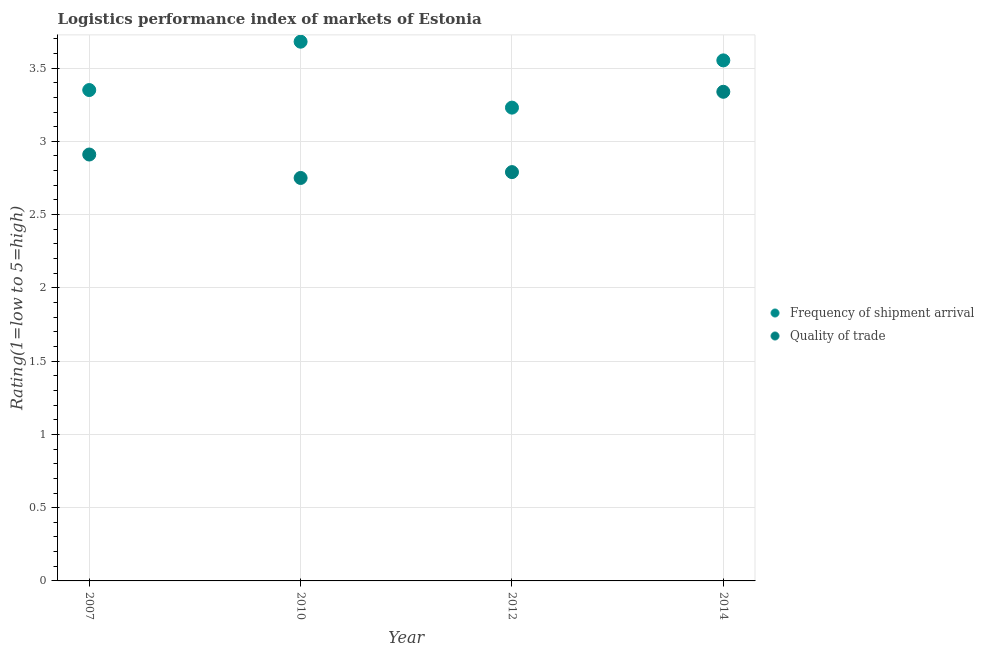What is the lpi of frequency of shipment arrival in 2012?
Ensure brevity in your answer.  3.23. Across all years, what is the maximum lpi of frequency of shipment arrival?
Your response must be concise. 3.68. Across all years, what is the minimum lpi quality of trade?
Offer a very short reply. 2.75. In which year was the lpi quality of trade maximum?
Ensure brevity in your answer.  2014. What is the total lpi of frequency of shipment arrival in the graph?
Give a very brief answer. 13.81. What is the difference between the lpi of frequency of shipment arrival in 2010 and that in 2014?
Provide a short and direct response. 0.13. What is the difference between the lpi quality of trade in 2010 and the lpi of frequency of shipment arrival in 2012?
Ensure brevity in your answer.  -0.48. What is the average lpi quality of trade per year?
Provide a succinct answer. 2.95. In the year 2010, what is the difference between the lpi of frequency of shipment arrival and lpi quality of trade?
Give a very brief answer. 0.93. In how many years, is the lpi of frequency of shipment arrival greater than 1.8?
Your response must be concise. 4. What is the ratio of the lpi of frequency of shipment arrival in 2007 to that in 2014?
Your response must be concise. 0.94. Is the difference between the lpi of frequency of shipment arrival in 2010 and 2012 greater than the difference between the lpi quality of trade in 2010 and 2012?
Your answer should be compact. Yes. What is the difference between the highest and the second highest lpi quality of trade?
Provide a short and direct response. 0.43. What is the difference between the highest and the lowest lpi of frequency of shipment arrival?
Give a very brief answer. 0.45. In how many years, is the lpi of frequency of shipment arrival greater than the average lpi of frequency of shipment arrival taken over all years?
Your answer should be very brief. 2. Is the sum of the lpi of frequency of shipment arrival in 2010 and 2012 greater than the maximum lpi quality of trade across all years?
Give a very brief answer. Yes. Does the lpi of frequency of shipment arrival monotonically increase over the years?
Keep it short and to the point. No. Is the lpi quality of trade strictly less than the lpi of frequency of shipment arrival over the years?
Provide a succinct answer. Yes. How many years are there in the graph?
Offer a very short reply. 4. What is the difference between two consecutive major ticks on the Y-axis?
Offer a very short reply. 0.5. Where does the legend appear in the graph?
Make the answer very short. Center right. How are the legend labels stacked?
Offer a terse response. Vertical. What is the title of the graph?
Keep it short and to the point. Logistics performance index of markets of Estonia. Does "Export" appear as one of the legend labels in the graph?
Your answer should be compact. No. What is the label or title of the Y-axis?
Give a very brief answer. Rating(1=low to 5=high). What is the Rating(1=low to 5=high) in Frequency of shipment arrival in 2007?
Your answer should be very brief. 3.35. What is the Rating(1=low to 5=high) in Quality of trade in 2007?
Provide a short and direct response. 2.91. What is the Rating(1=low to 5=high) in Frequency of shipment arrival in 2010?
Your answer should be compact. 3.68. What is the Rating(1=low to 5=high) in Quality of trade in 2010?
Give a very brief answer. 2.75. What is the Rating(1=low to 5=high) in Frequency of shipment arrival in 2012?
Offer a very short reply. 3.23. What is the Rating(1=low to 5=high) in Quality of trade in 2012?
Give a very brief answer. 2.79. What is the Rating(1=low to 5=high) of Frequency of shipment arrival in 2014?
Provide a succinct answer. 3.55. What is the Rating(1=low to 5=high) of Quality of trade in 2014?
Ensure brevity in your answer.  3.34. Across all years, what is the maximum Rating(1=low to 5=high) in Frequency of shipment arrival?
Your answer should be very brief. 3.68. Across all years, what is the maximum Rating(1=low to 5=high) of Quality of trade?
Keep it short and to the point. 3.34. Across all years, what is the minimum Rating(1=low to 5=high) in Frequency of shipment arrival?
Your answer should be compact. 3.23. Across all years, what is the minimum Rating(1=low to 5=high) of Quality of trade?
Your answer should be very brief. 2.75. What is the total Rating(1=low to 5=high) in Frequency of shipment arrival in the graph?
Make the answer very short. 13.81. What is the total Rating(1=low to 5=high) of Quality of trade in the graph?
Offer a very short reply. 11.79. What is the difference between the Rating(1=low to 5=high) in Frequency of shipment arrival in 2007 and that in 2010?
Make the answer very short. -0.33. What is the difference between the Rating(1=low to 5=high) in Quality of trade in 2007 and that in 2010?
Your answer should be compact. 0.16. What is the difference between the Rating(1=low to 5=high) of Frequency of shipment arrival in 2007 and that in 2012?
Ensure brevity in your answer.  0.12. What is the difference between the Rating(1=low to 5=high) in Quality of trade in 2007 and that in 2012?
Offer a terse response. 0.12. What is the difference between the Rating(1=low to 5=high) in Frequency of shipment arrival in 2007 and that in 2014?
Keep it short and to the point. -0.2. What is the difference between the Rating(1=low to 5=high) of Quality of trade in 2007 and that in 2014?
Make the answer very short. -0.43. What is the difference between the Rating(1=low to 5=high) of Frequency of shipment arrival in 2010 and that in 2012?
Keep it short and to the point. 0.45. What is the difference between the Rating(1=low to 5=high) of Quality of trade in 2010 and that in 2012?
Your answer should be compact. -0.04. What is the difference between the Rating(1=low to 5=high) in Frequency of shipment arrival in 2010 and that in 2014?
Keep it short and to the point. 0.13. What is the difference between the Rating(1=low to 5=high) of Quality of trade in 2010 and that in 2014?
Your response must be concise. -0.59. What is the difference between the Rating(1=low to 5=high) of Frequency of shipment arrival in 2012 and that in 2014?
Your answer should be very brief. -0.32. What is the difference between the Rating(1=low to 5=high) of Quality of trade in 2012 and that in 2014?
Your answer should be compact. -0.55. What is the difference between the Rating(1=low to 5=high) in Frequency of shipment arrival in 2007 and the Rating(1=low to 5=high) in Quality of trade in 2010?
Give a very brief answer. 0.6. What is the difference between the Rating(1=low to 5=high) of Frequency of shipment arrival in 2007 and the Rating(1=low to 5=high) of Quality of trade in 2012?
Offer a terse response. 0.56. What is the difference between the Rating(1=low to 5=high) in Frequency of shipment arrival in 2007 and the Rating(1=low to 5=high) in Quality of trade in 2014?
Offer a very short reply. 0.01. What is the difference between the Rating(1=low to 5=high) in Frequency of shipment arrival in 2010 and the Rating(1=low to 5=high) in Quality of trade in 2012?
Offer a terse response. 0.89. What is the difference between the Rating(1=low to 5=high) of Frequency of shipment arrival in 2010 and the Rating(1=low to 5=high) of Quality of trade in 2014?
Give a very brief answer. 0.34. What is the difference between the Rating(1=low to 5=high) in Frequency of shipment arrival in 2012 and the Rating(1=low to 5=high) in Quality of trade in 2014?
Your answer should be very brief. -0.11. What is the average Rating(1=low to 5=high) in Frequency of shipment arrival per year?
Ensure brevity in your answer.  3.45. What is the average Rating(1=low to 5=high) in Quality of trade per year?
Provide a succinct answer. 2.95. In the year 2007, what is the difference between the Rating(1=low to 5=high) in Frequency of shipment arrival and Rating(1=low to 5=high) in Quality of trade?
Keep it short and to the point. 0.44. In the year 2010, what is the difference between the Rating(1=low to 5=high) in Frequency of shipment arrival and Rating(1=low to 5=high) in Quality of trade?
Give a very brief answer. 0.93. In the year 2012, what is the difference between the Rating(1=low to 5=high) in Frequency of shipment arrival and Rating(1=low to 5=high) in Quality of trade?
Make the answer very short. 0.44. In the year 2014, what is the difference between the Rating(1=low to 5=high) in Frequency of shipment arrival and Rating(1=low to 5=high) in Quality of trade?
Keep it short and to the point. 0.21. What is the ratio of the Rating(1=low to 5=high) of Frequency of shipment arrival in 2007 to that in 2010?
Give a very brief answer. 0.91. What is the ratio of the Rating(1=low to 5=high) of Quality of trade in 2007 to that in 2010?
Give a very brief answer. 1.06. What is the ratio of the Rating(1=low to 5=high) in Frequency of shipment arrival in 2007 to that in 2012?
Make the answer very short. 1.04. What is the ratio of the Rating(1=low to 5=high) of Quality of trade in 2007 to that in 2012?
Your answer should be compact. 1.04. What is the ratio of the Rating(1=low to 5=high) of Frequency of shipment arrival in 2007 to that in 2014?
Your response must be concise. 0.94. What is the ratio of the Rating(1=low to 5=high) of Quality of trade in 2007 to that in 2014?
Your response must be concise. 0.87. What is the ratio of the Rating(1=low to 5=high) in Frequency of shipment arrival in 2010 to that in 2012?
Your response must be concise. 1.14. What is the ratio of the Rating(1=low to 5=high) in Quality of trade in 2010 to that in 2012?
Your answer should be compact. 0.99. What is the ratio of the Rating(1=low to 5=high) in Frequency of shipment arrival in 2010 to that in 2014?
Provide a short and direct response. 1.04. What is the ratio of the Rating(1=low to 5=high) of Quality of trade in 2010 to that in 2014?
Offer a terse response. 0.82. What is the ratio of the Rating(1=low to 5=high) in Frequency of shipment arrival in 2012 to that in 2014?
Ensure brevity in your answer.  0.91. What is the ratio of the Rating(1=low to 5=high) in Quality of trade in 2012 to that in 2014?
Your response must be concise. 0.84. What is the difference between the highest and the second highest Rating(1=low to 5=high) in Frequency of shipment arrival?
Offer a very short reply. 0.13. What is the difference between the highest and the second highest Rating(1=low to 5=high) in Quality of trade?
Your answer should be very brief. 0.43. What is the difference between the highest and the lowest Rating(1=low to 5=high) of Frequency of shipment arrival?
Provide a succinct answer. 0.45. What is the difference between the highest and the lowest Rating(1=low to 5=high) in Quality of trade?
Give a very brief answer. 0.59. 